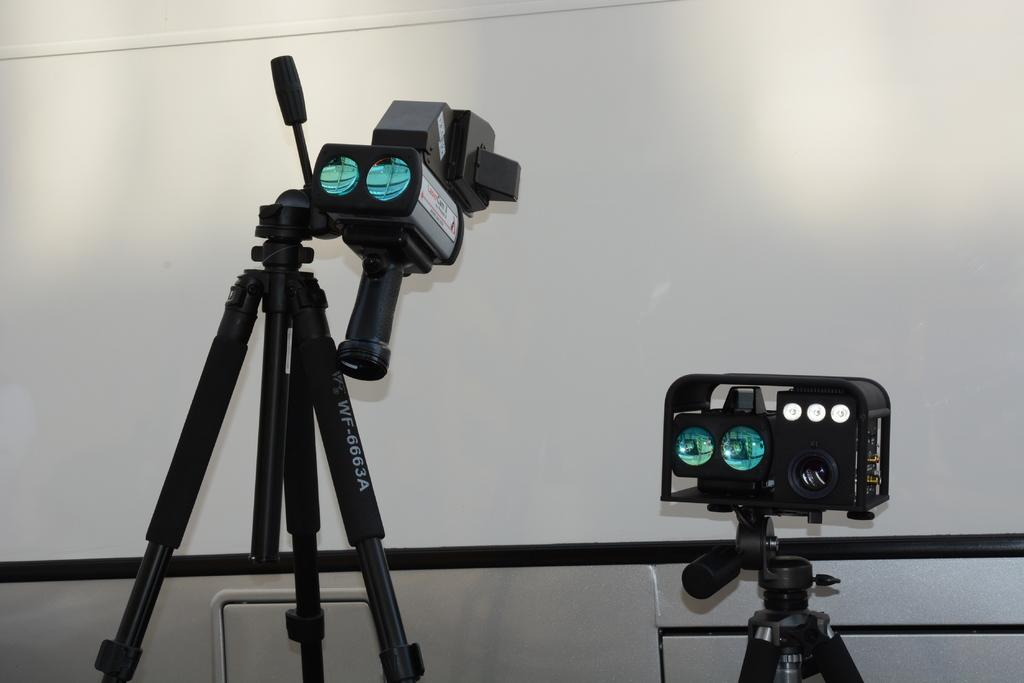What can be seen in the foreground of the image? There are two gadgets in the foreground of the image. What type of destruction can be seen in the image caused by the tank? There is no tank or destruction present in the image; it only features two gadgets in the foreground. How many clocks are visible in the image? There is no mention of clocks in the provided fact, so it cannot be determined how many are visible in the image. 